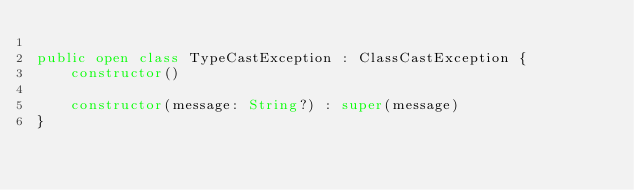<code> <loc_0><loc_0><loc_500><loc_500><_Kotlin_>
public open class TypeCastException : ClassCastException {
    constructor()

    constructor(message: String?) : super(message)
}
</code> 